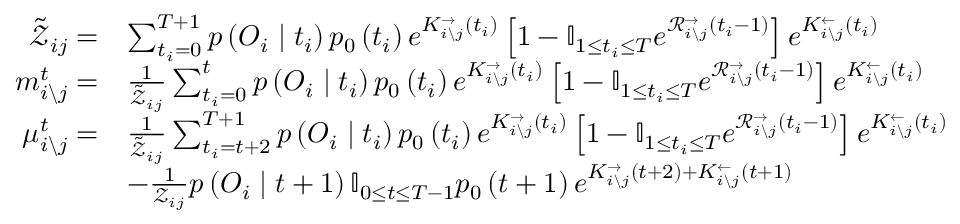<formula> <loc_0><loc_0><loc_500><loc_500>\begin{array} { r l } { \tilde { \mathcal { Z } } _ { i j } = } & { \sum _ { t _ { i } = 0 } ^ { T + 1 } p \left ( O _ { i } | t _ { i } \right ) p _ { 0 } \left ( t _ { i } \right ) e ^ { K _ { i \ j } ^ { \rightarrow } \left ( t _ { i } \right ) } \left [ 1 - \mathbb { I } _ { 1 \leq t _ { i } \leq T } e ^ { \mathcal { R } _ { i \ j } ^ { \rightarrow } \left ( t _ { i } - 1 \right ) } \right ] e ^ { K _ { i \ j } ^ { \leftarrow } \left ( t _ { i } \right ) } } \\ { m _ { i \ j } ^ { t } = } & { \frac { 1 } { \tilde { \mathcal { Z } } _ { i j } } \sum _ { t _ { i } = 0 } ^ { t } p \left ( O _ { i } | t _ { i } \right ) p _ { 0 } \left ( t _ { i } \right ) e ^ { K _ { i \ j } ^ { \rightarrow } \left ( t _ { i } \right ) } \left [ 1 - \mathbb { I } _ { 1 \leq t _ { i } \leq T } e ^ { \mathcal { R } _ { i \ j } ^ { \rightarrow } \left ( t _ { i } - 1 \right ) } \right ] e ^ { K _ { i \ j } ^ { \leftarrow } \left ( t _ { i } \right ) } } \\ { \mu _ { i \ j } ^ { t } = } & { \frac { 1 } { \tilde { \mathcal { Z } } _ { i j } } \sum _ { t _ { i } = t + 2 } ^ { T + 1 } p \left ( O _ { i } | t _ { i } \right ) p _ { 0 } \left ( t _ { i } \right ) e ^ { K _ { i \ j } ^ { \rightarrow } \left ( t _ { i } \right ) } \left [ 1 - \mathbb { I } _ { 1 \leq t _ { i } \leq T } e ^ { \mathcal { R } _ { i \ j } ^ { \rightarrow } \left ( t _ { i } - 1 \right ) } \right ] e ^ { K _ { i \ j } ^ { \leftarrow } \left ( t _ { i } \right ) } } \\ & { - \frac { 1 } { \mathcal { Z } _ { i j } } p \left ( O _ { i } | t + 1 \right ) \mathbb { I } _ { 0 \leq t \leq T - 1 } p _ { 0 } \left ( t + 1 \right ) e ^ { K _ { i \ j } ^ { \rightarrow } \left ( t + 2 \right ) + K _ { i \ j } ^ { \leftarrow } \left ( t + 1 \right ) } } \end{array}</formula> 